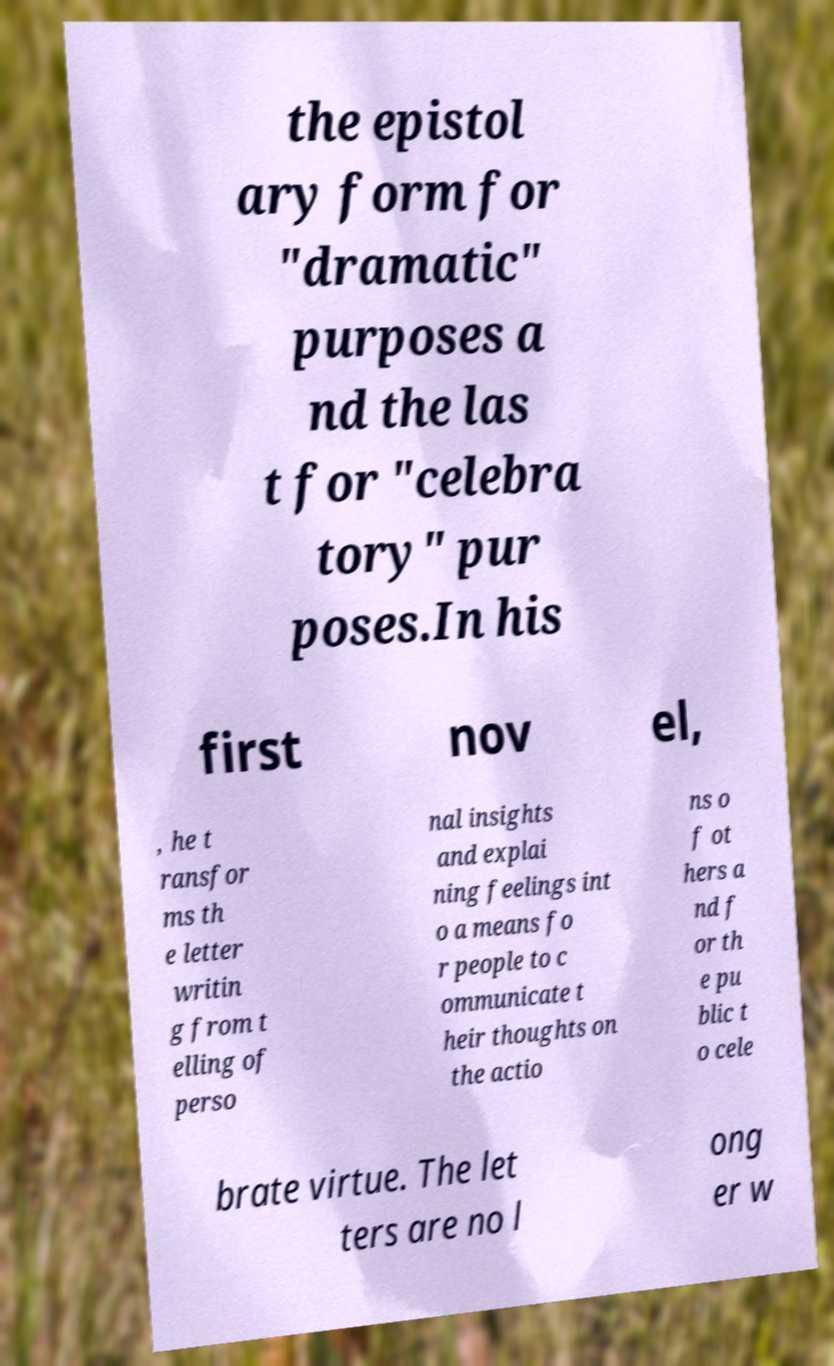Can you read and provide the text displayed in the image?This photo seems to have some interesting text. Can you extract and type it out for me? the epistol ary form for "dramatic" purposes a nd the las t for "celebra tory" pur poses.In his first nov el, , he t ransfor ms th e letter writin g from t elling of perso nal insights and explai ning feelings int o a means fo r people to c ommunicate t heir thoughts on the actio ns o f ot hers a nd f or th e pu blic t o cele brate virtue. The let ters are no l ong er w 